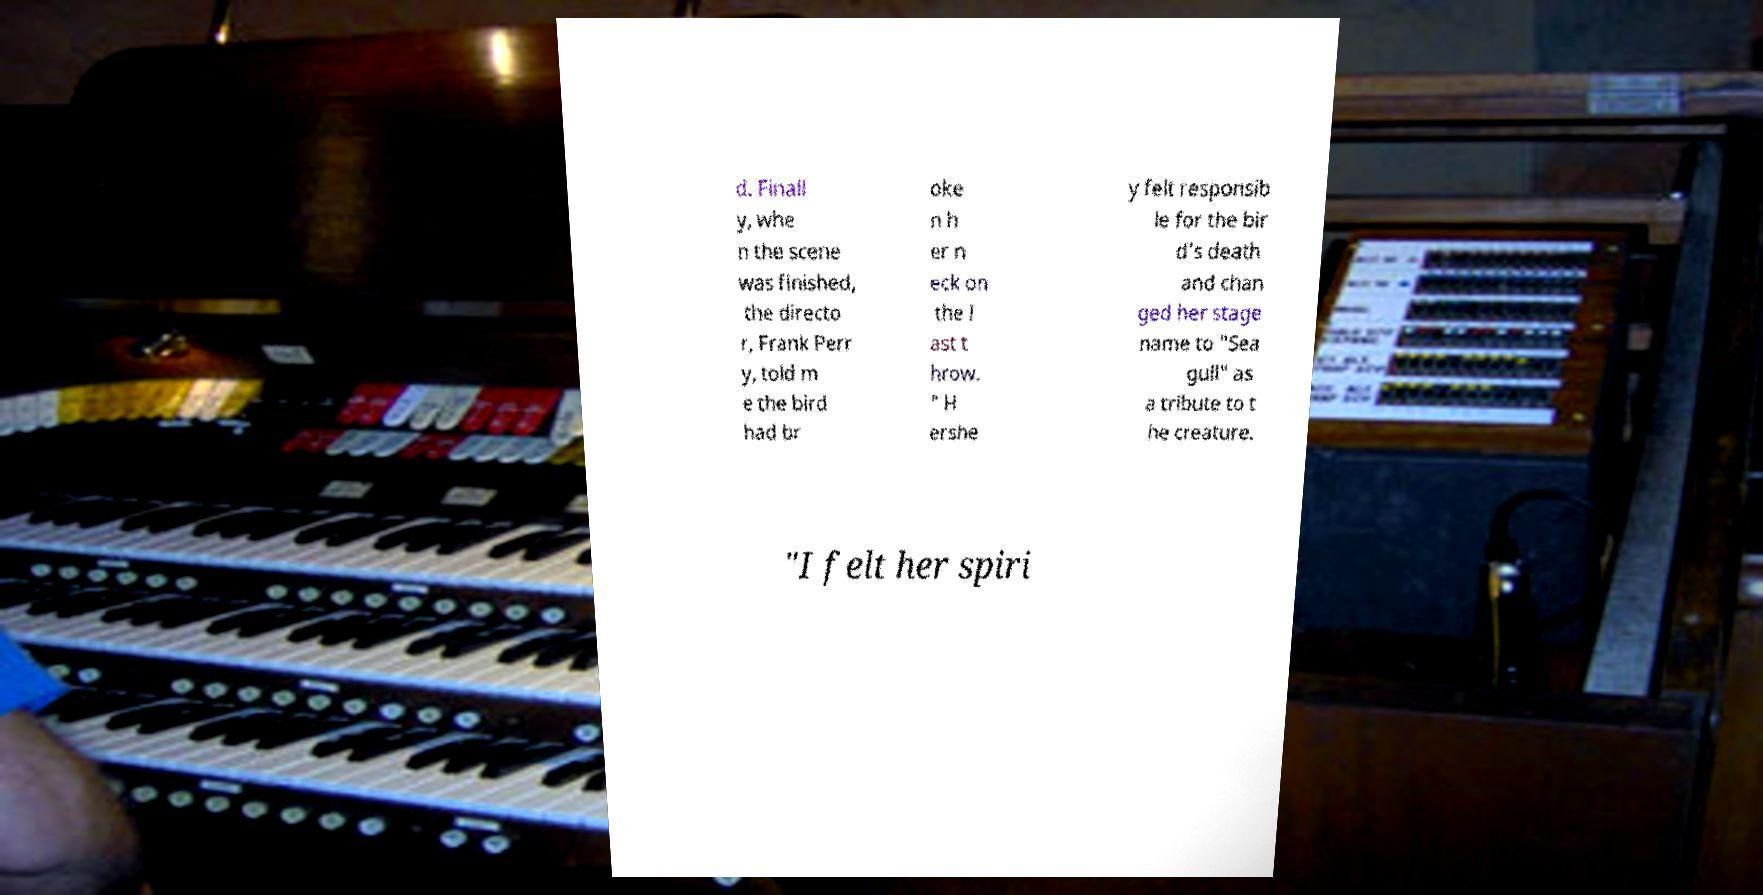For documentation purposes, I need the text within this image transcribed. Could you provide that? d. Finall y, whe n the scene was finished, the directo r, Frank Perr y, told m e the bird had br oke n h er n eck on the l ast t hrow. " H ershe y felt responsib le for the bir d's death and chan ged her stage name to "Sea gull" as a tribute to t he creature. "I felt her spiri 